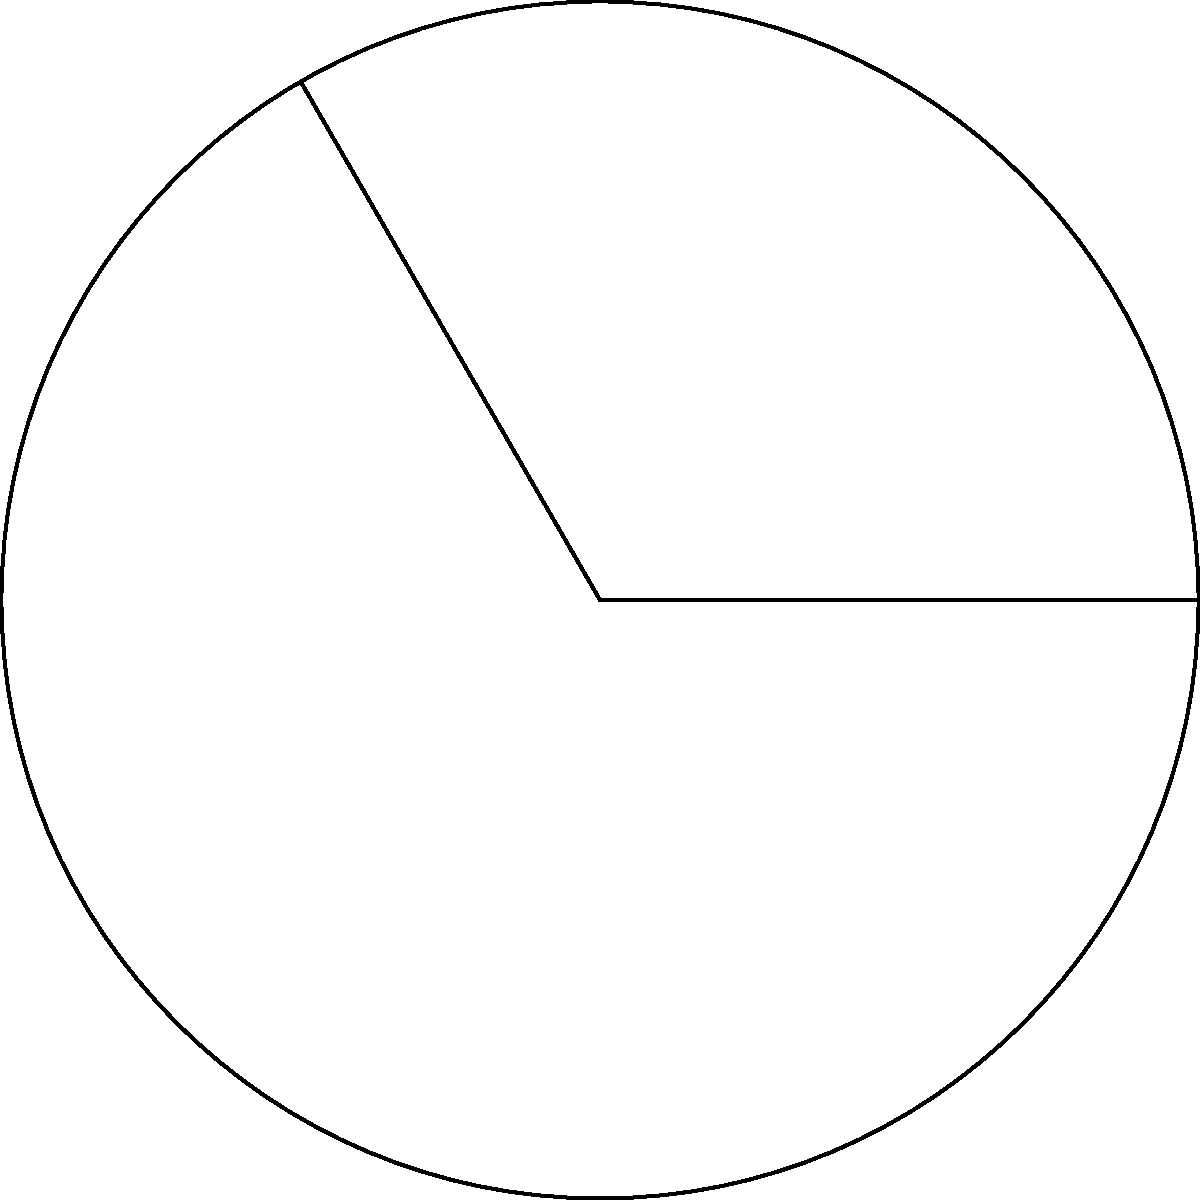During a reconstruction project in your neighborhood, you notice a circular garden with a radius of 3 cm. A section of the garden, forming a sector with a central angle of 120°, needs special attention. Calculate the area of this sector to determine the amount of resources needed for its restoration. To find the area of a circular sector, we'll follow these steps:

1) The formula for the area of a circular sector is:
   $$A = \frac{\theta}{360°} \pi r^2$$
   where $\theta$ is the central angle in degrees and $r$ is the radius.

2) We're given:
   - Radius $r = 3$ cm
   - Central angle $\theta = 120°$

3) Let's substitute these values into the formula:
   $$A = \frac{120°}{360°} \pi (3\text{ cm})^2$$

4) Simplify:
   $$A = \frac{1}{3} \pi (9\text{ cm}^2)$$
   $$A = 3\pi\text{ cm}^2$$

5) If we need a decimal approximation:
   $$A \approx 9.42\text{ cm}^2$$

The area of the sector is $3\pi\text{ cm}^2$ or approximately 9.42 cm².
Answer: $3\pi\text{ cm}^2$ 